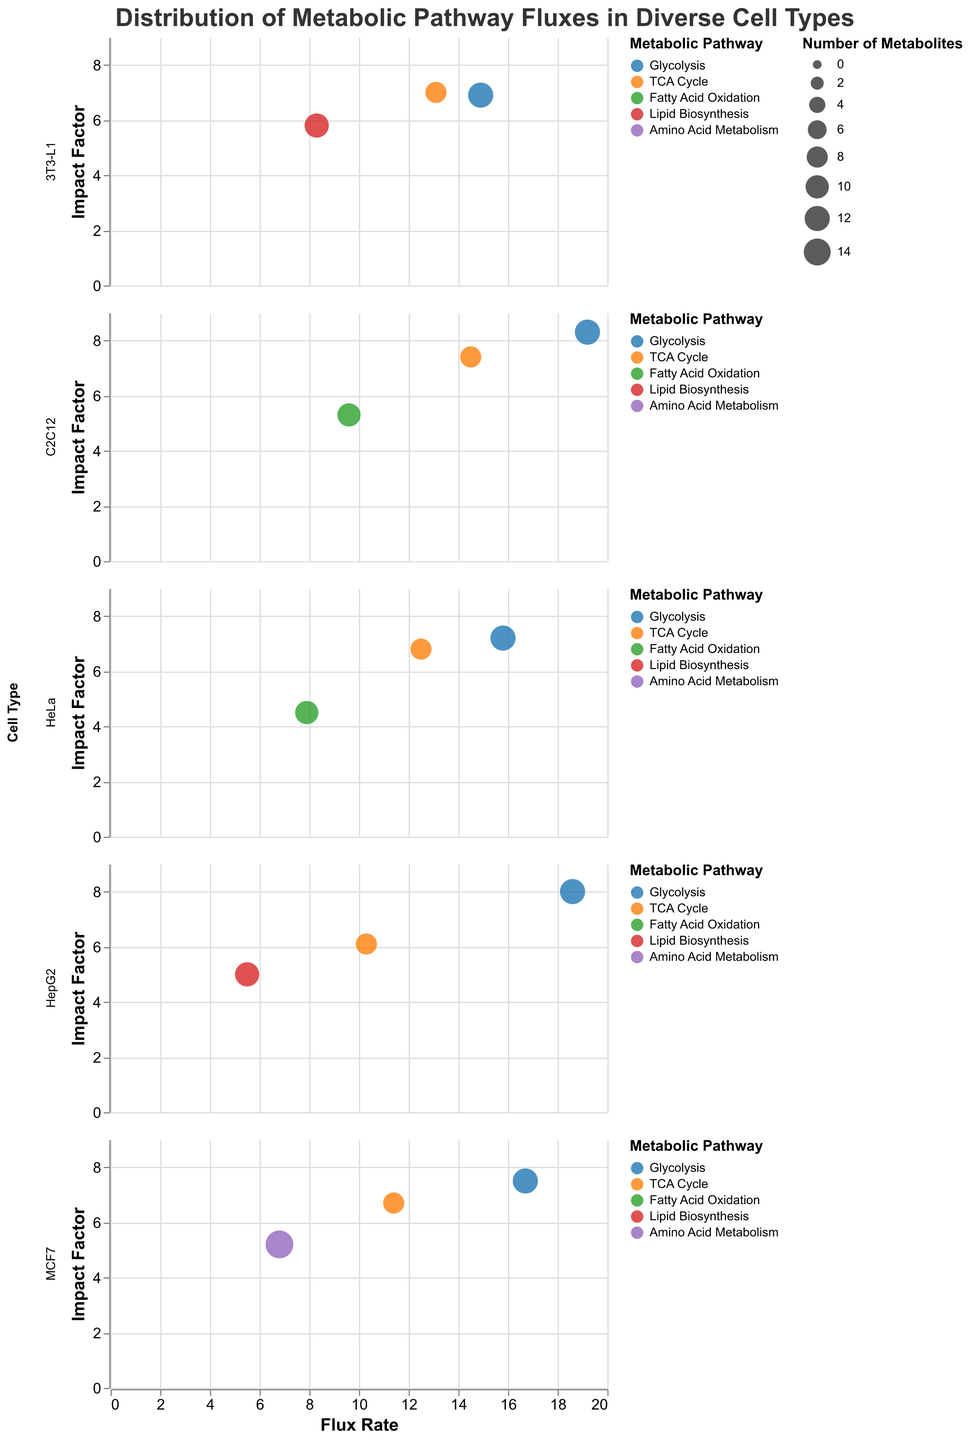Which cell type has the highest Flux Rate in Glycolysis? Glycolysis has a specific color assigned to it. By examining the Glycolysis points' Flux Rates, C2C12 has the highest rate at 19.2.
Answer: C2C12 How many metabolic pathways are represented for the HeLa cell type? By counting the different colored bubbles in the HeLa cell type subplot, we see Glycolysis, TCA Cycle, and Fatty Acid Oxidation, totaling 3 pathways.
Answer: 3 Which metabolic pathway in HepG2 has the smallest number of metabolites? The sizes of the bubbles correlate with the number of metabolites. The smallest bubble for HepG2 corresponds to the TCA Cycle with 8 metabolites.
Answer: TCA Cycle Compare the Impact Factor of Glycolysis between HeLa and MCF7 cells. Which one is higher? By checking the y-axis positions of the Glycolysis bubbles, the MCF7 Impact Factor is 7.5 compared to HeLa's 7.2. Hence, MCF7 is higher.
Answer: MCF7 What is the average Flux Rate of the TCA Cycle across all cell types? Sum the Flux Rates for TCA Cycle (12.5 + 10.3 + 11.4 + 13.1 + 14.5) and divide by the number of entries (5). Calculation: (12.5 + 10.3 + 11.4 + 13.1 + 14.5) / 5 = 61.8 / 5 = 12.36.
Answer: 12.36 Identify the cell type and pathway combination with the highest Impact Factor overall. The highest point on the y-axis across all subplots indicates C2C12 Glycolysis with an Impact Factor of 8.3.
Answer: C2C12 Glycolysis How does the number of metabolites in Fatty Acid Oxidation for C2C12 compare to HepG2's Lipid Biosynthesis? Compare the bubble sizes; C2C12's Fatty Acid Oxidation has 10 metabolites, while HepG2's Lipid Biosynthesis has 11.
Answer: HepG2 has more Is there a cell type where the Flux Rate for Lipid Biosynthesis is higher than that for Fatty Acid Oxidation? Compare these pathways across cell types with both. Lipid Biosynthesis in HepG2 (5.5) is less than Fatty Acid Oxidation, while in 3T3-L1 Lipid Biosynthesis (8.3) is more significant than Fatty Acid Oxidation.
Answer: 3T3-L1 Which metabolic pathway in MCF7 has the smallest Impact Factor, and what is its value? By inspecting the y-axis positions of bubbles in MCF7, the Amino Acid Metabolism pathway has the smallest Impact Factor of 5.2.
Answer: Amino Acid Metabolism, 5.2 